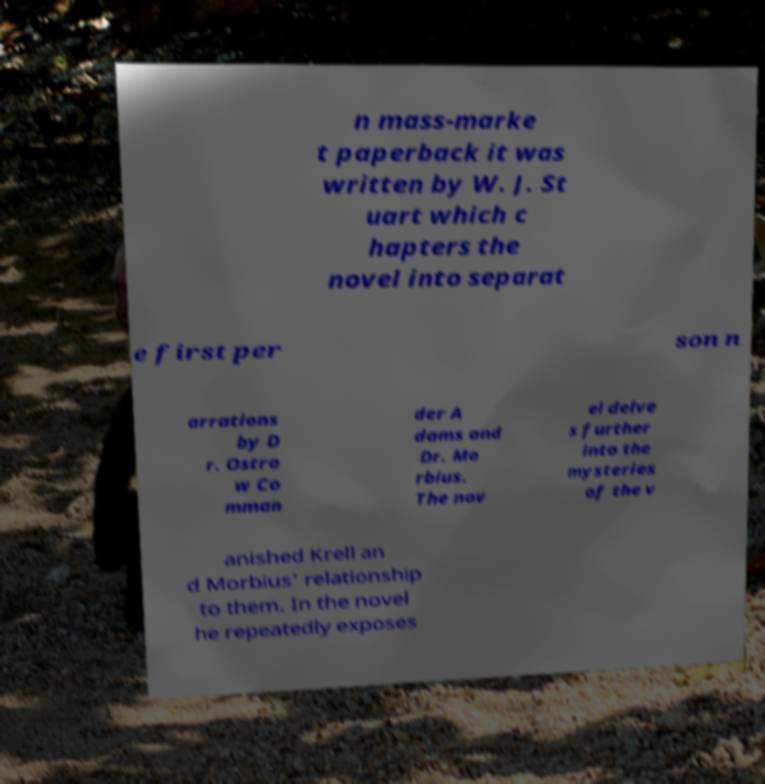Can you accurately transcribe the text from the provided image for me? n mass-marke t paperback it was written by W. J. St uart which c hapters the novel into separat e first per son n arrations by D r. Ostro w Co mman der A dams and Dr. Mo rbius. The nov el delve s further into the mysteries of the v anished Krell an d Morbius' relationship to them. In the novel he repeatedly exposes 